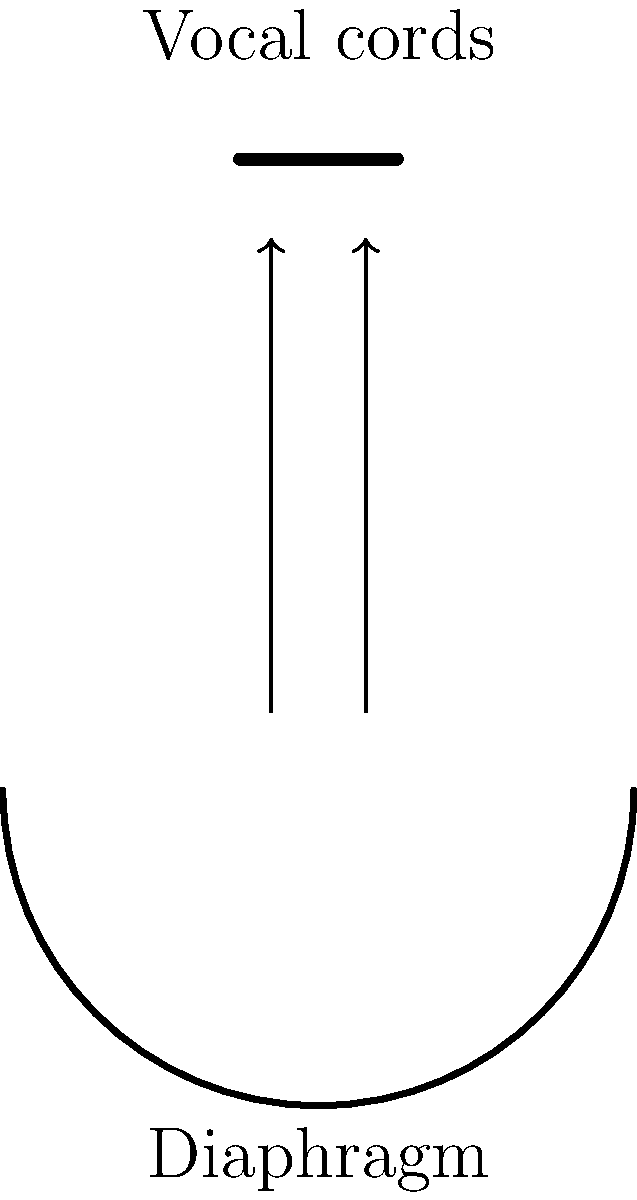As a singer, you know the importance of breath control and vocal cord tension. In the diagram, $F_d$ represents the force exerted by the diaphragm, and $F_v$ represents the tension in the vocal cords. If the diaphragm exerts a force of 50 N and each vocal cord experiences a tension of 15 N, what is the ratio of the total vocal cord tension to the diaphragm force? To solve this problem, let's break it down into steps:

1. Identify the given forces:
   - Diaphragm force ($F_d$) = 50 N
   - Tension in each vocal cord ($F_v$) = 15 N

2. Calculate the total tension in the vocal cords:
   - There are two vocal cords, so we need to sum their tensions
   - Total vocal cord tension = $F_v + F_v = 15 N + 15 N = 30 N$

3. Set up the ratio of total vocal cord tension to diaphragm force:
   - Ratio = (Total vocal cord tension) : (Diaphragm force)
   - Ratio = 30 N : 50 N

4. Simplify the ratio:
   - Divide both numbers by their greatest common divisor (10)
   - Simplified ratio = 3 : 5

Therefore, the ratio of the total vocal cord tension to the diaphragm force is 3:5.
Answer: 3:5 